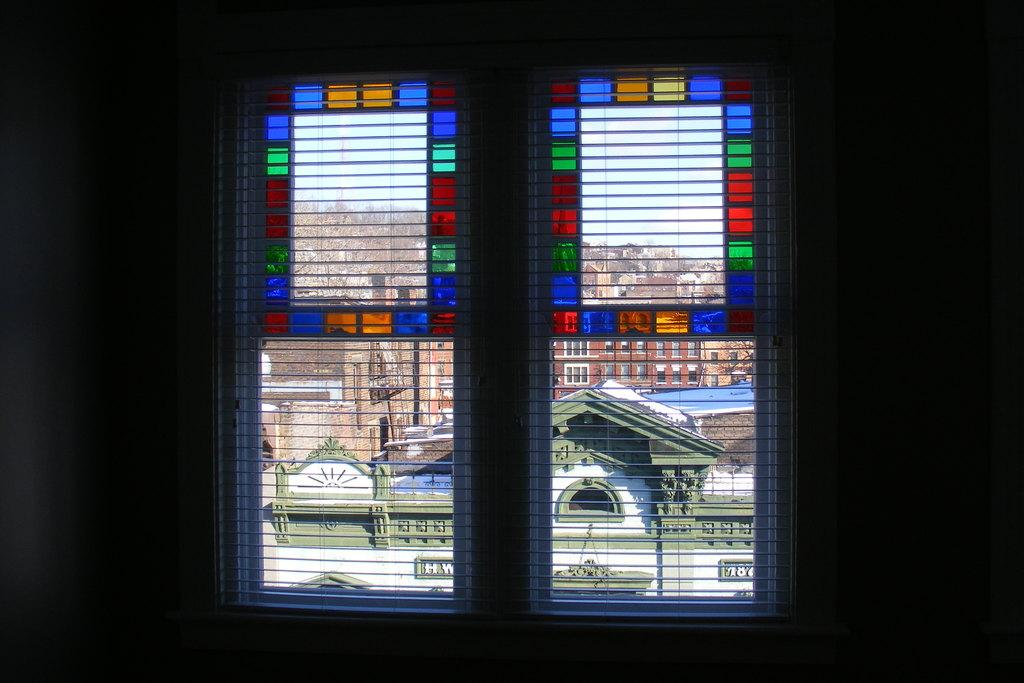What is the lighting condition in the room in the image? The room in the image is dark. What feature of the room allows for natural light to enter? There are windows in the room. What can be seen through the windows in the image? Buildings with windows and the sky are visible through the windows. How much mass does the leg of the table in the image have? There is no table or leg mentioned in the image, so it is impossible to determine the mass of a leg. 